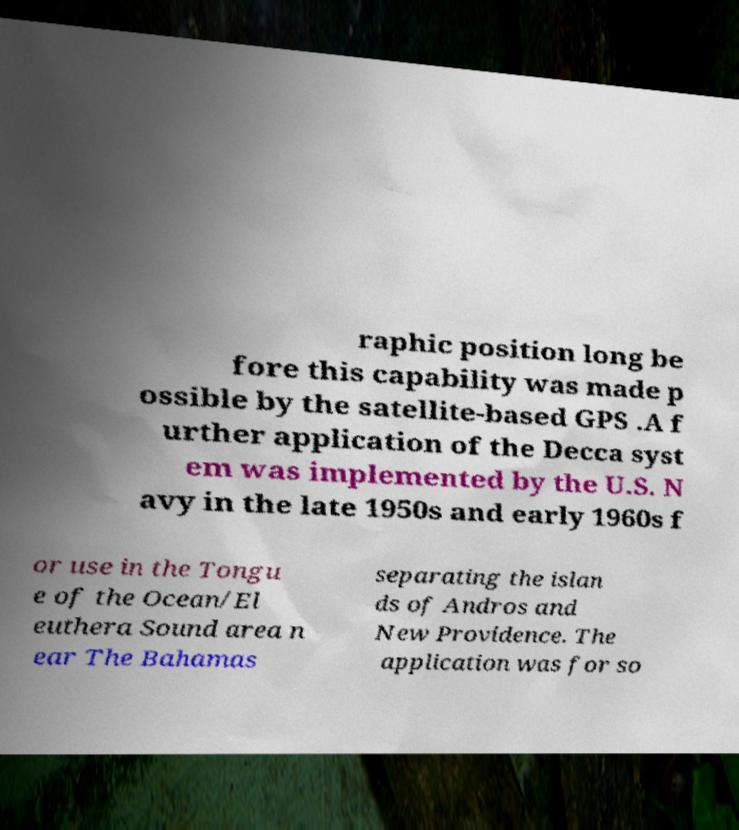Can you accurately transcribe the text from the provided image for me? raphic position long be fore this capability was made p ossible by the satellite-based GPS .A f urther application of the Decca syst em was implemented by the U.S. N avy in the late 1950s and early 1960s f or use in the Tongu e of the Ocean/El euthera Sound area n ear The Bahamas separating the islan ds of Andros and New Providence. The application was for so 